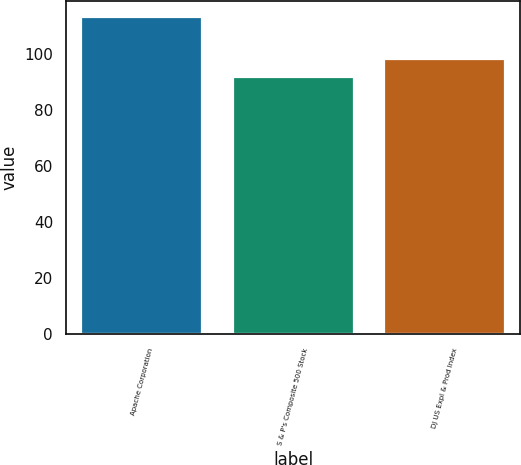Convert chart. <chart><loc_0><loc_0><loc_500><loc_500><bar_chart><fcel>Apache Corporation<fcel>S & P's Composite 500 Stock<fcel>DJ US Expl & Prod Index<nl><fcel>113.16<fcel>91.68<fcel>98.26<nl></chart> 